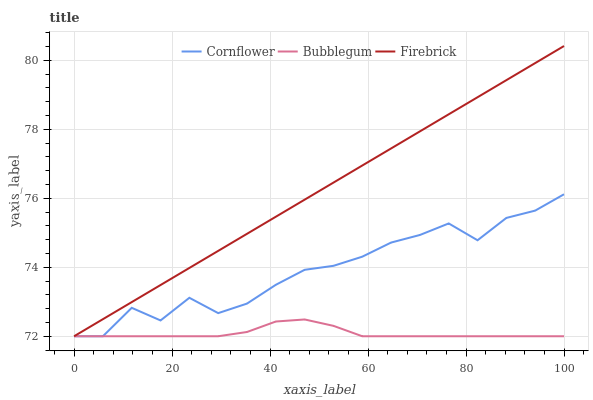Does Bubblegum have the minimum area under the curve?
Answer yes or no. Yes. Does Firebrick have the maximum area under the curve?
Answer yes or no. Yes. Does Firebrick have the minimum area under the curve?
Answer yes or no. No. Does Bubblegum have the maximum area under the curve?
Answer yes or no. No. Is Firebrick the smoothest?
Answer yes or no. Yes. Is Cornflower the roughest?
Answer yes or no. Yes. Is Bubblegum the smoothest?
Answer yes or no. No. Is Bubblegum the roughest?
Answer yes or no. No. Does Cornflower have the lowest value?
Answer yes or no. Yes. Does Firebrick have the highest value?
Answer yes or no. Yes. Does Bubblegum have the highest value?
Answer yes or no. No. Does Cornflower intersect Bubblegum?
Answer yes or no. Yes. Is Cornflower less than Bubblegum?
Answer yes or no. No. Is Cornflower greater than Bubblegum?
Answer yes or no. No. 